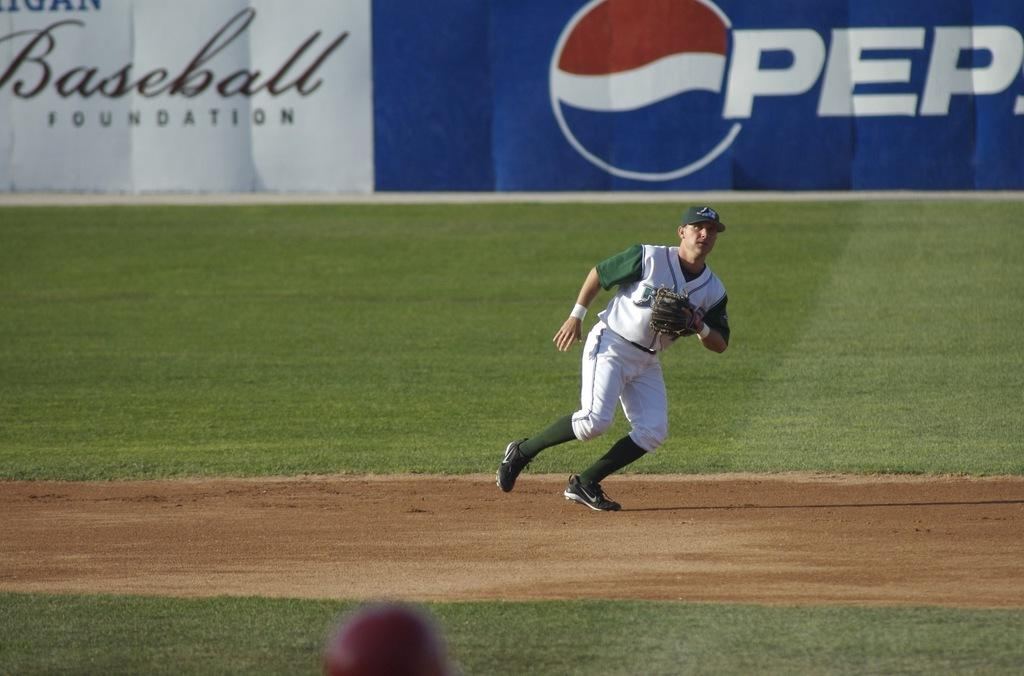Provide a one-sentence caption for the provided image. Both Pepsi and The Baseball Foundation have bought ad space at the sidelines of this baseball field. 